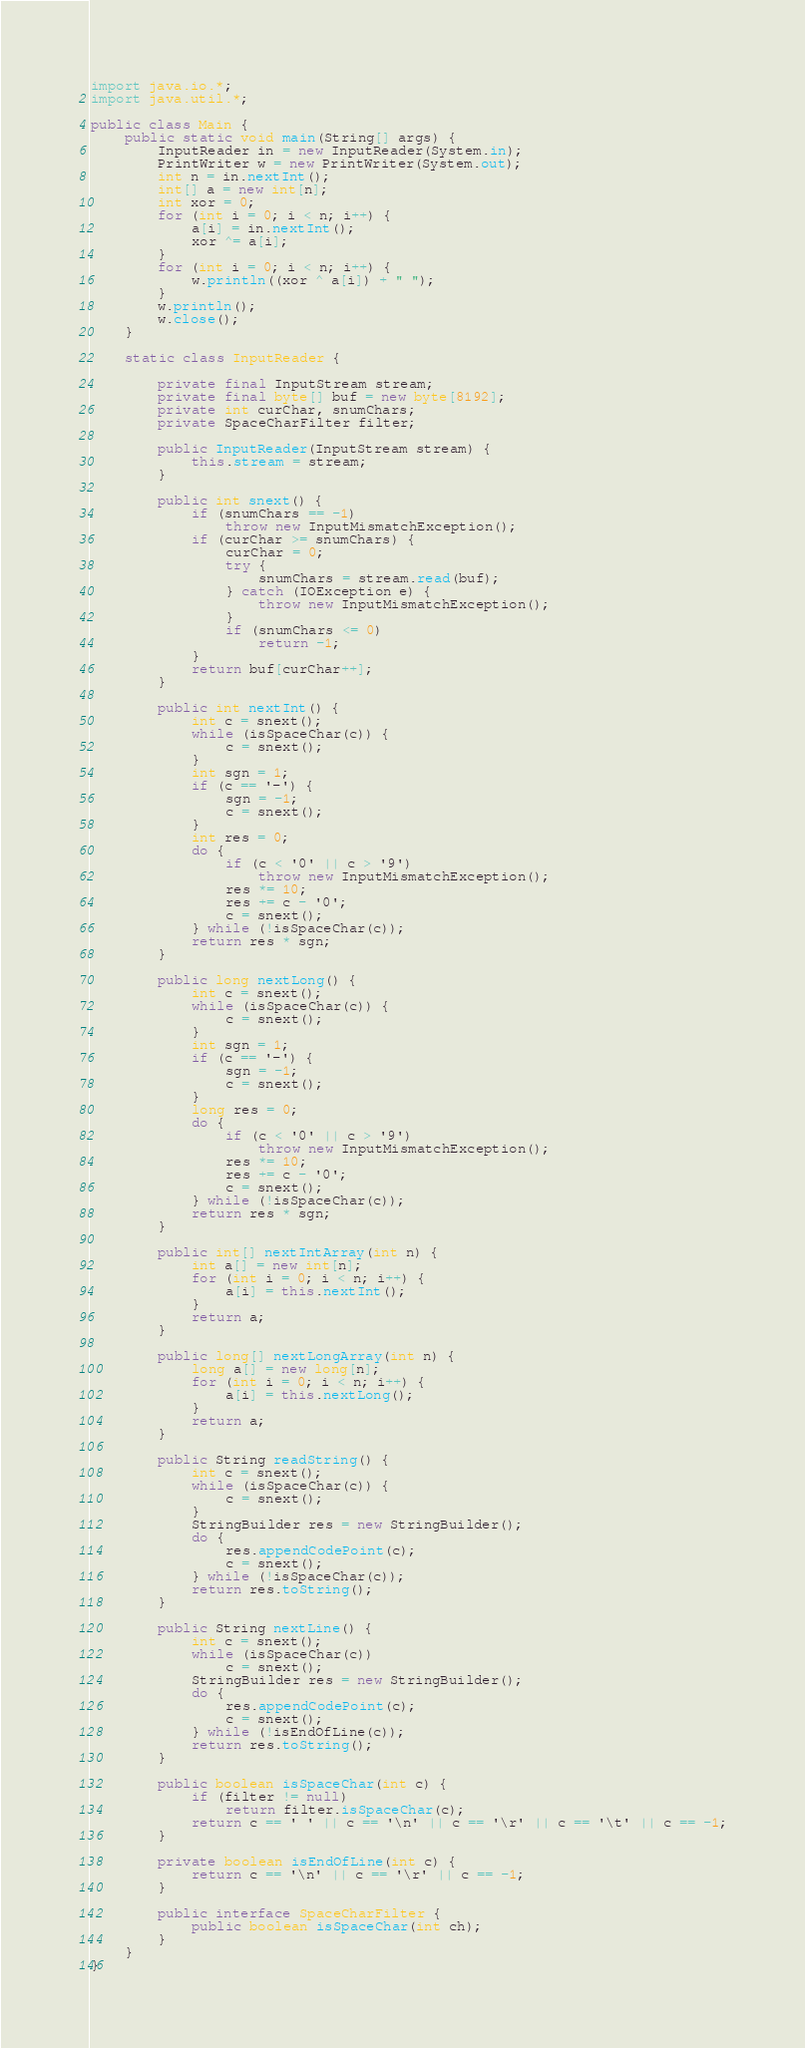Convert code to text. <code><loc_0><loc_0><loc_500><loc_500><_Java_>
import java.io.*;
import java.util.*;

public class Main {
    public static void main(String[] args) {
        InputReader in = new InputReader(System.in);
        PrintWriter w = new PrintWriter(System.out);
        int n = in.nextInt();
        int[] a = new int[n];
        int xor = 0;
        for (int i = 0; i < n; i++) {
            a[i] = in.nextInt();
            xor ^= a[i];
        }
        for (int i = 0; i < n; i++) {
            w.println((xor ^ a[i]) + " ");
        }
        w.println();
        w.close();
    }

    static class InputReader {

        private final InputStream stream;
        private final byte[] buf = new byte[8192];
        private int curChar, snumChars;
        private SpaceCharFilter filter;

        public InputReader(InputStream stream) {
            this.stream = stream;
        }

        public int snext() {
            if (snumChars == -1)
                throw new InputMismatchException();
            if (curChar >= snumChars) {
                curChar = 0;
                try {
                    snumChars = stream.read(buf);
                } catch (IOException e) {
                    throw new InputMismatchException();
                }
                if (snumChars <= 0)
                    return -1;
            }
            return buf[curChar++];
        }

        public int nextInt() {
            int c = snext();
            while (isSpaceChar(c)) {
                c = snext();
            }
            int sgn = 1;
            if (c == '-') {
                sgn = -1;
                c = snext();
            }
            int res = 0;
            do {
                if (c < '0' || c > '9')
                    throw new InputMismatchException();
                res *= 10;
                res += c - '0';
                c = snext();
            } while (!isSpaceChar(c));
            return res * sgn;
        }

        public long nextLong() {
            int c = snext();
            while (isSpaceChar(c)) {
                c = snext();
            }
            int sgn = 1;
            if (c == '-') {
                sgn = -1;
                c = snext();
            }
            long res = 0;
            do {
                if (c < '0' || c > '9')
                    throw new InputMismatchException();
                res *= 10;
                res += c - '0';
                c = snext();
            } while (!isSpaceChar(c));
            return res * sgn;
        }

        public int[] nextIntArray(int n) {
            int a[] = new int[n];
            for (int i = 0; i < n; i++) {
                a[i] = this.nextInt();
            }
            return a;
        }

        public long[] nextLongArray(int n) {
            long a[] = new long[n];
            for (int i = 0; i < n; i++) {
                a[i] = this.nextLong();
            }
            return a;
        }

        public String readString() {
            int c = snext();
            while (isSpaceChar(c)) {
                c = snext();
            }
            StringBuilder res = new StringBuilder();
            do {
                res.appendCodePoint(c);
                c = snext();
            } while (!isSpaceChar(c));
            return res.toString();
        }

        public String nextLine() {
            int c = snext();
            while (isSpaceChar(c))
                c = snext();
            StringBuilder res = new StringBuilder();
            do {
                res.appendCodePoint(c);
                c = snext();
            } while (!isEndOfLine(c));
            return res.toString();
        }

        public boolean isSpaceChar(int c) {
            if (filter != null)
                return filter.isSpaceChar(c);
            return c == ' ' || c == '\n' || c == '\r' || c == '\t' || c == -1;
        }

        private boolean isEndOfLine(int c) {
            return c == '\n' || c == '\r' || c == -1;
        }

        public interface SpaceCharFilter {
            public boolean isSpaceChar(int ch);
        }
    }
}</code> 